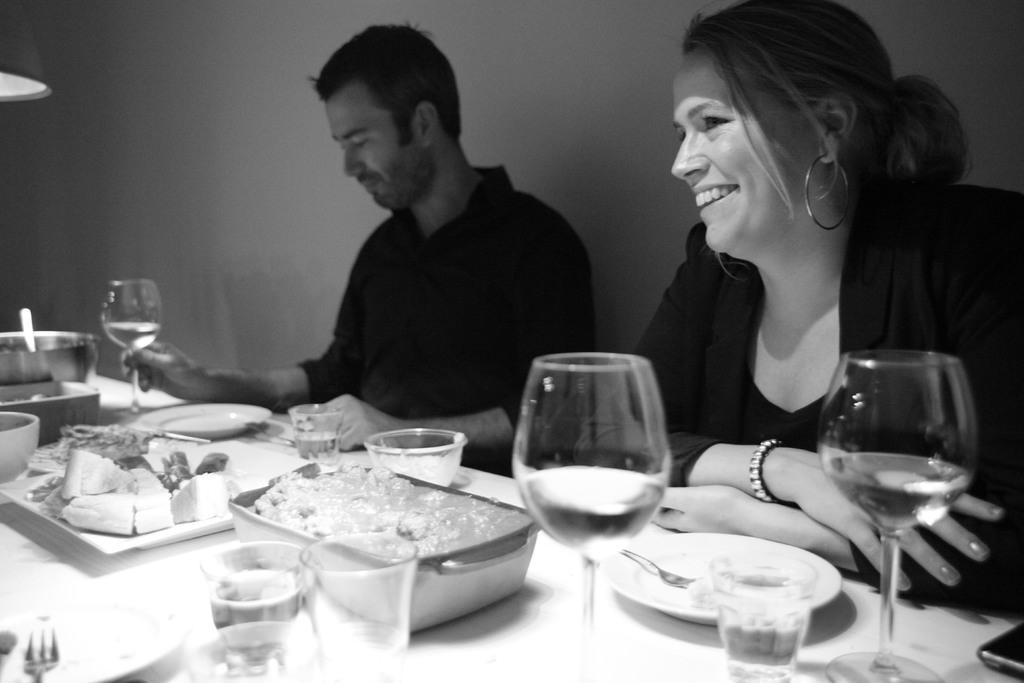Please provide a concise description of this image. In this picture we can see two people are seated in front of the table, and we can find glasses, bowls, plates and some food on the table. 